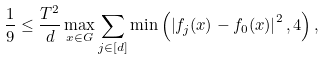<formula> <loc_0><loc_0><loc_500><loc_500>\frac { 1 } { 9 } \leq \frac { T ^ { 2 } } { d } \max _ { x \in G } \sum _ { j \in [ d ] } \min \left ( \left | f _ { j } ( x ) - f _ { 0 } ( x ) \right | ^ { 2 } , 4 \right ) ,</formula> 